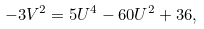<formula> <loc_0><loc_0><loc_500><loc_500>- 3 V ^ { 2 } = 5 U ^ { 4 } - 6 0 U ^ { 2 } + 3 6 ,</formula> 